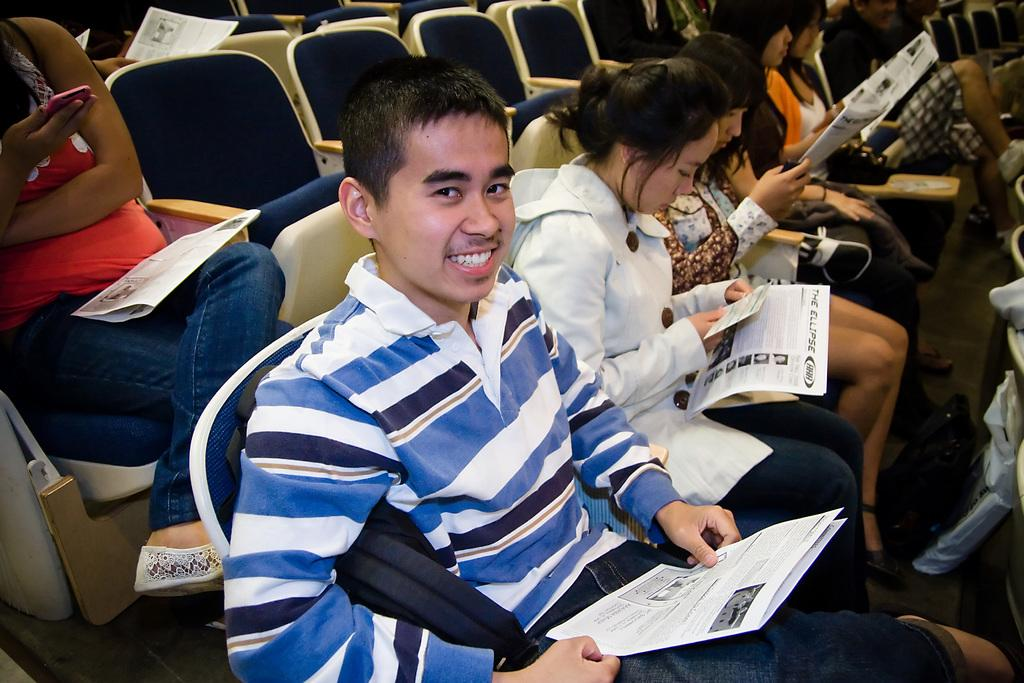What is happening in the image involving a group of people? In the image, there is a group of people sitting on chairs and holding papers. Can you describe the actions of the people in the image? One person is holding a mobile, and there is a person smiling in the center of the group. What might the people be doing based on the items they are holding? The people might be attending a meeting or discussing something related to the papers they are holding. What type of pin can be seen on the person's shirt in the image? There is no pin visible on any person's shirt in the image. What discovery was made by the group during their breakfast in the image? There is no mention of breakfast or any discovery in the image; the people are holding papers and a mobile. 